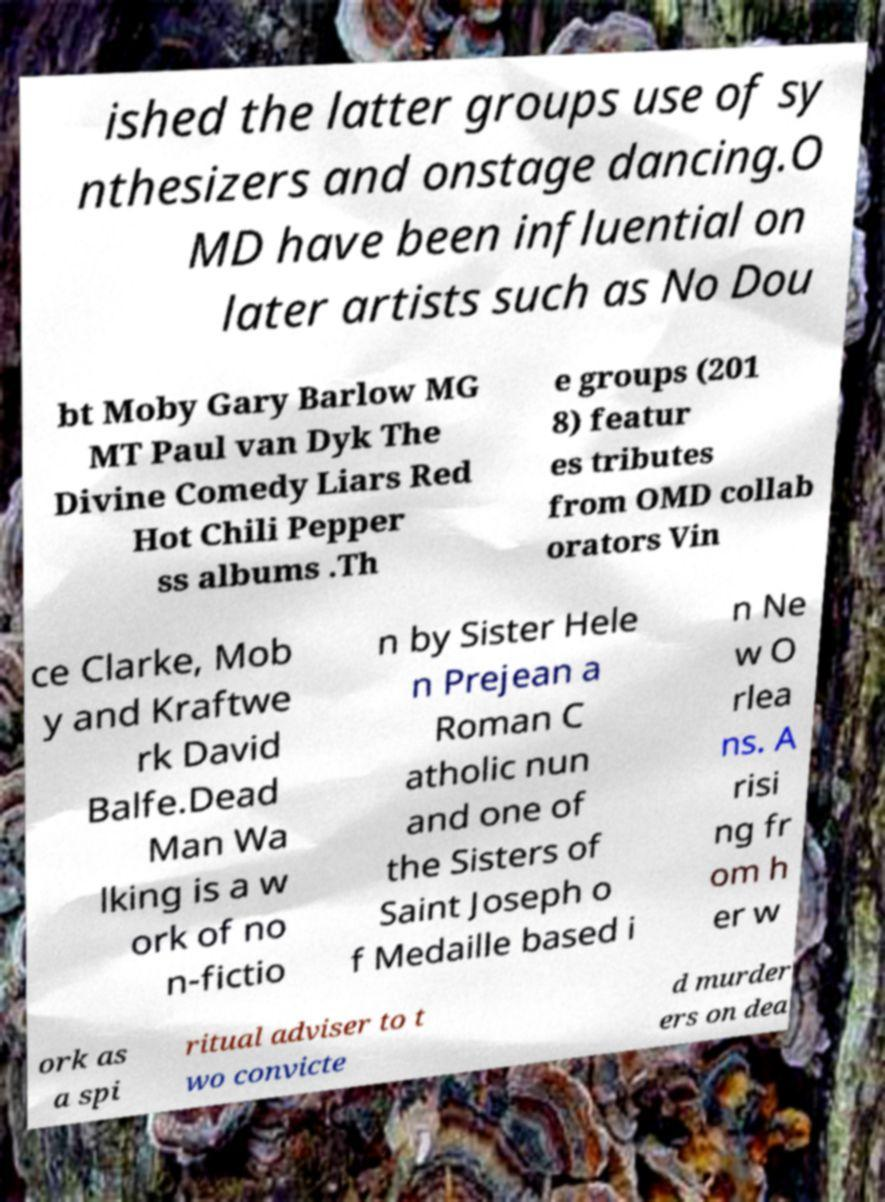Could you assist in decoding the text presented in this image and type it out clearly? ished the latter groups use of sy nthesizers and onstage dancing.O MD have been influential on later artists such as No Dou bt Moby Gary Barlow MG MT Paul van Dyk The Divine Comedy Liars Red Hot Chili Pepper ss albums .Th e groups (201 8) featur es tributes from OMD collab orators Vin ce Clarke, Mob y and Kraftwe rk David Balfe.Dead Man Wa lking is a w ork of no n-fictio n by Sister Hele n Prejean a Roman C atholic nun and one of the Sisters of Saint Joseph o f Medaille based i n Ne w O rlea ns. A risi ng fr om h er w ork as a spi ritual adviser to t wo convicte d murder ers on dea 